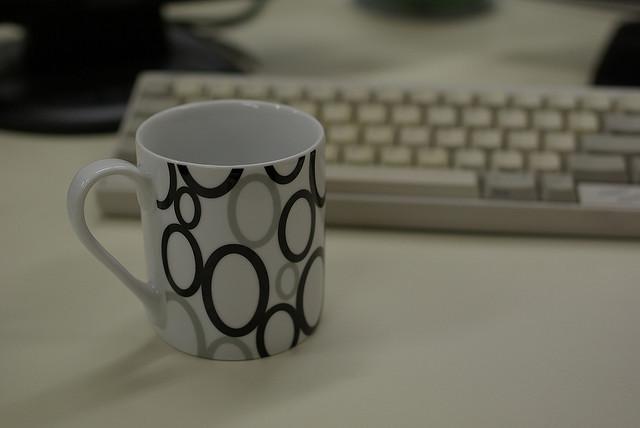What color is the keyboard?
Write a very short answer. White. What is the object in front of the keyboard?
Give a very brief answer. Mug. Based on the shadows is there more than one light source?
Keep it brief. Yes. Is this a beautiful cup?
Quick response, please. No. 